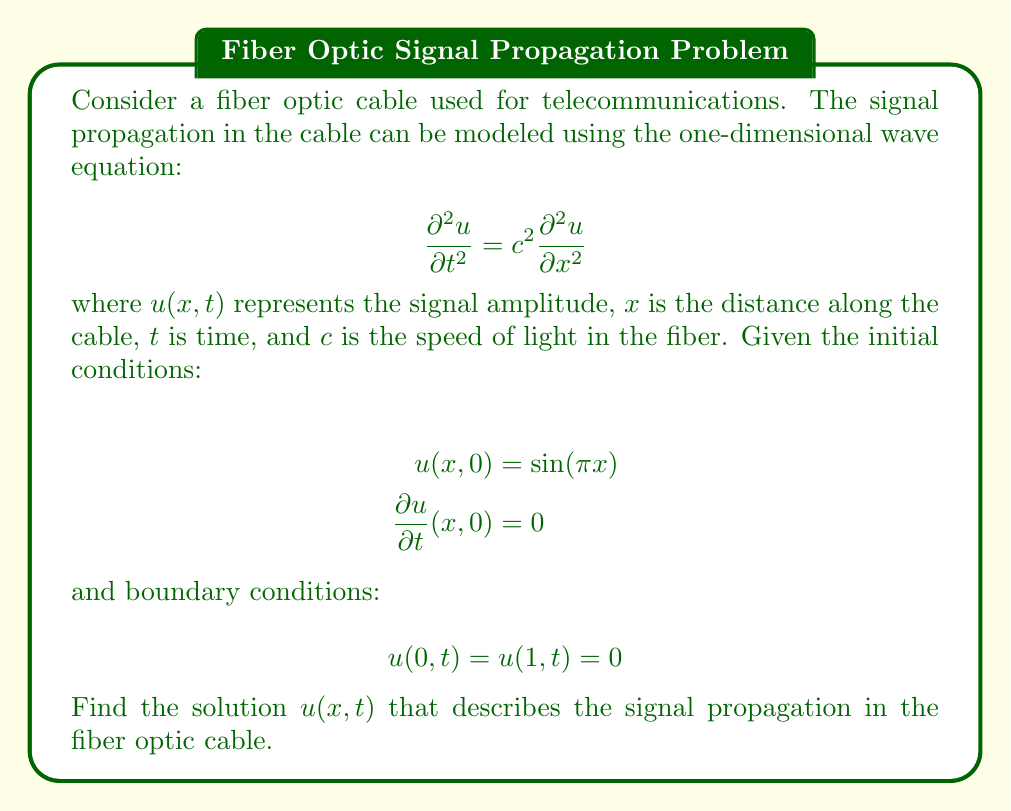Can you answer this question? To solve this wave equation problem, we'll use the method of separation of variables, which is particularly relevant for telecommunications majors working on user interfaces, as it helps in understanding how signals propagate through time and space.

1. Assume a solution of the form $u(x,t) = X(x)T(t)$.

2. Substitute this into the wave equation:
   $$X(x)T''(t) = c^2X''(x)T(t)$$

3. Separate variables:
   $$\frac{T''(t)}{c^2T(t)} = \frac{X''(x)}{X(x)} = -\lambda$$
   where $\lambda$ is a constant.

4. This gives us two ordinary differential equations:
   $$T''(t) + \lambda c^2T(t) = 0$$
   $$X''(x) + \lambda X(x) = 0$$

5. The boundary conditions $u(0,t) = u(1,t) = 0$ imply $X(0) = X(1) = 0$. This, combined with the $X$ equation, gives us an eigenvalue problem with solutions:
   $$X_n(x) = \sin(n\pi x), \quad \lambda_n = n^2\pi^2, \quad n = 1,2,3,\ldots$$

6. The general solution for $T(t)$ is:
   $$T_n(t) = A_n\cos(n\pi ct) + B_n\sin(n\pi ct)$$

7. The general solution for $u(x,t)$ is:
   $$u(x,t) = \sum_{n=1}^{\infty} [A_n\cos(n\pi ct) + B_n\sin(n\pi ct)]\sin(n\pi x)$$

8. Apply the initial conditions:
   - $u(x,0) = \sin(\pi x)$ implies $A_1 = 1$ and $A_n = 0$ for $n > 1$
   - $\frac{\partial u}{\partial t}(x,0) = 0$ implies $B_n = 0$ for all $n$

Therefore, the final solution is:
$$u(x,t) = \sin(\pi x)\cos(\pi ct)$$

This solution represents a standing wave in the fiber optic cable, which is crucial for understanding signal behavior in telecommunications applications.
Answer: $$u(x,t) = \sin(\pi x)\cos(\pi ct)$$ 